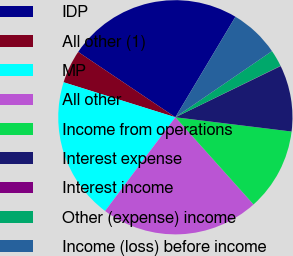Convert chart. <chart><loc_0><loc_0><loc_500><loc_500><pie_chart><fcel>IDP<fcel>All other (1)<fcel>MP<fcel>All other<fcel>Income from operations<fcel>Interest expense<fcel>Interest income<fcel>Other (expense) income<fcel>Income (loss) before income<nl><fcel>24.15%<fcel>4.59%<fcel>19.59%<fcel>21.87%<fcel>11.42%<fcel>9.14%<fcel>0.04%<fcel>2.32%<fcel>6.87%<nl></chart> 